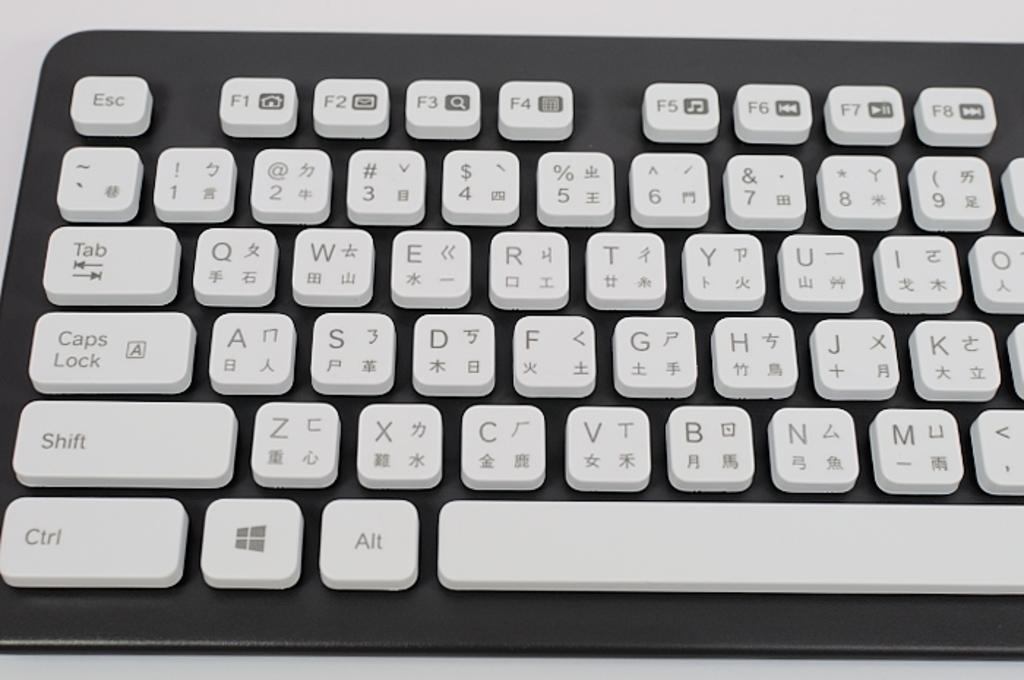<image>
Present a compact description of the photo's key features. White and black keyboard with the SHIFT key above the CTRL key. 